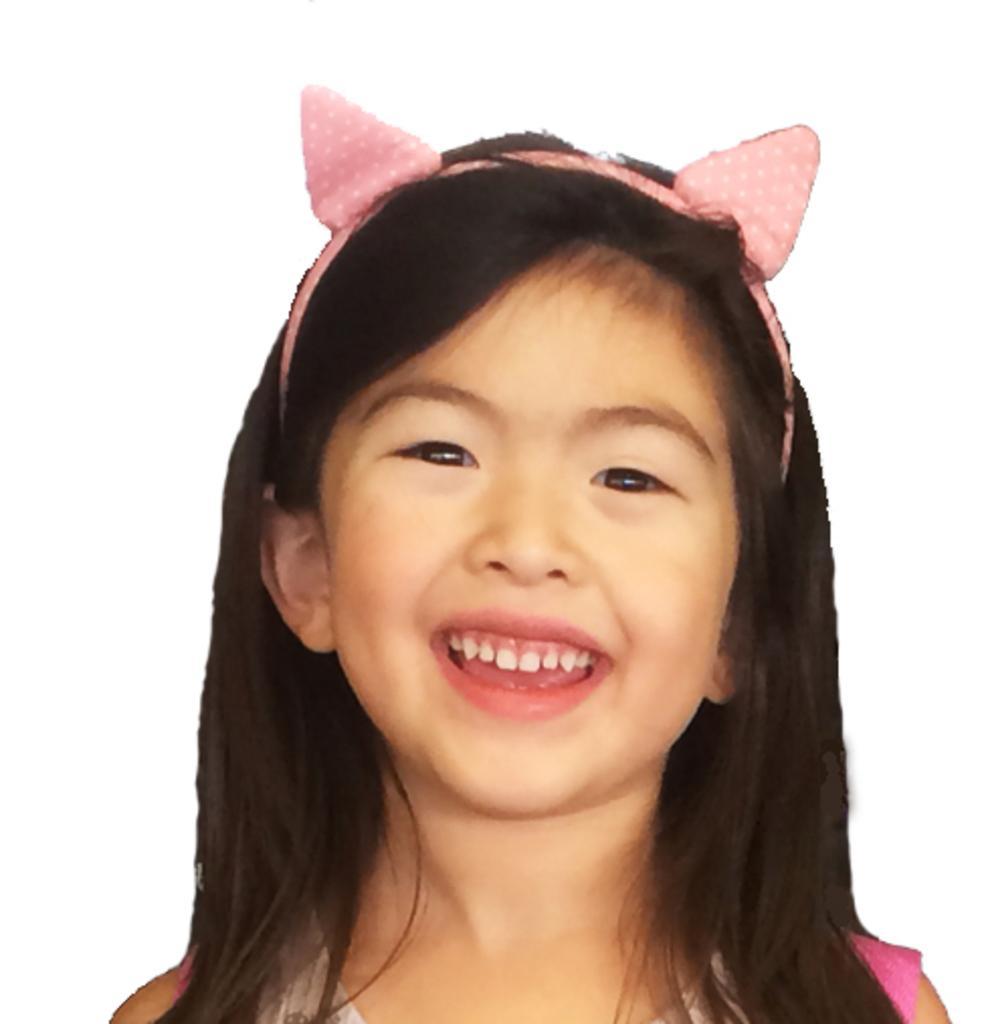Please provide a concise description of this image. In this picture we can see a girl is smiling, she wore a head wear, we can see a white color background. 